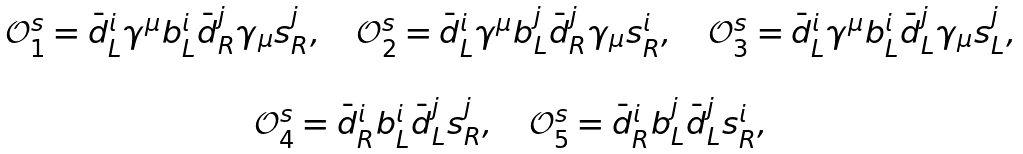<formula> <loc_0><loc_0><loc_500><loc_500>\begin{array} { c } \mathcal { O } ^ { s } _ { 1 } = \bar { d } ^ { i } _ { L } \gamma ^ { \mu } b ^ { i } _ { L } \bar { d } ^ { j } _ { R } \gamma _ { \mu } s ^ { j } _ { R } , \quad \mathcal { O } ^ { s } _ { 2 } = \bar { d } ^ { i } _ { L } \gamma ^ { \mu } b ^ { j } _ { L } \bar { d } ^ { j } _ { R } \gamma _ { \mu } s ^ { i } _ { R } , \quad \mathcal { O } ^ { s } _ { 3 } = \bar { d } ^ { i } _ { L } \gamma ^ { \mu } b ^ { i } _ { L } \bar { d } ^ { j } _ { L } \gamma _ { \mu } s ^ { j } _ { L } , \\ \\ \mathcal { O } ^ { s } _ { 4 } = \bar { d } ^ { i } _ { R } b ^ { i } _ { L } \bar { d } ^ { j } _ { L } s ^ { j } _ { R } , \quad \mathcal { O } ^ { s } _ { 5 } = \bar { d } ^ { i } _ { R } b ^ { j } _ { L } \bar { d } ^ { j } _ { L } s ^ { i } _ { R } , \end{array}</formula> 